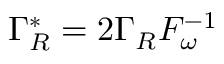Convert formula to latex. <formula><loc_0><loc_0><loc_500><loc_500>\Gamma _ { R } ^ { * } = 2 \Gamma _ { R } F _ { \omega } ^ { - 1 }</formula> 